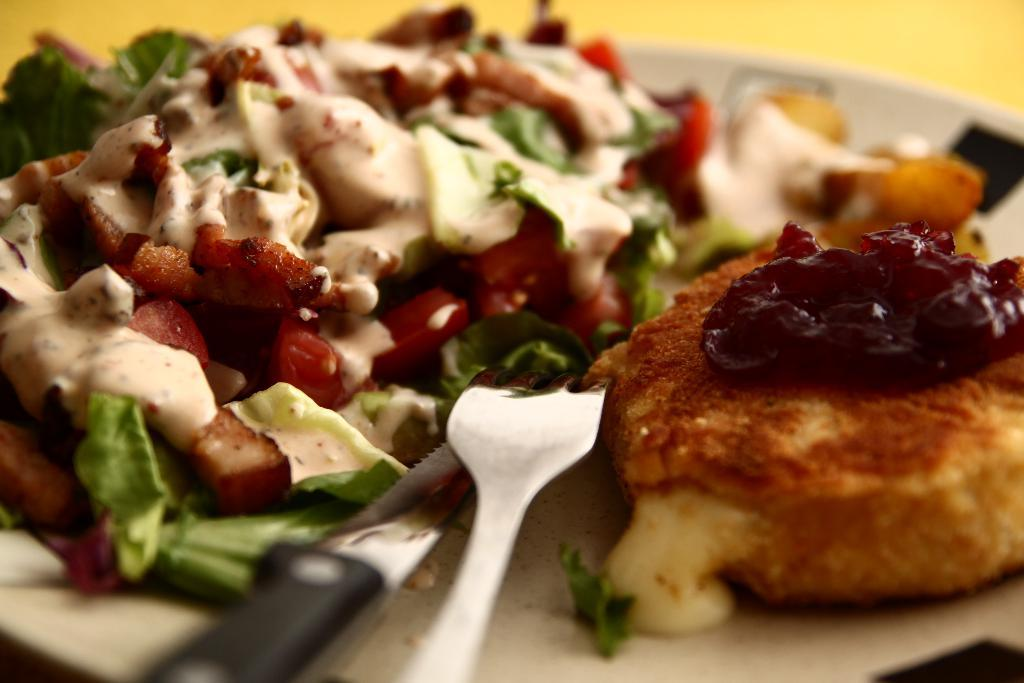What is located in the center of the image? There is a plate in the center of the image. What is on the plate? The plate contains food items. What utensils are present on the plate? There is a knife and a fork on the plate. How many boys are visible in the image? There are no boys present in the image; it only features a plate with food items and utensils. 